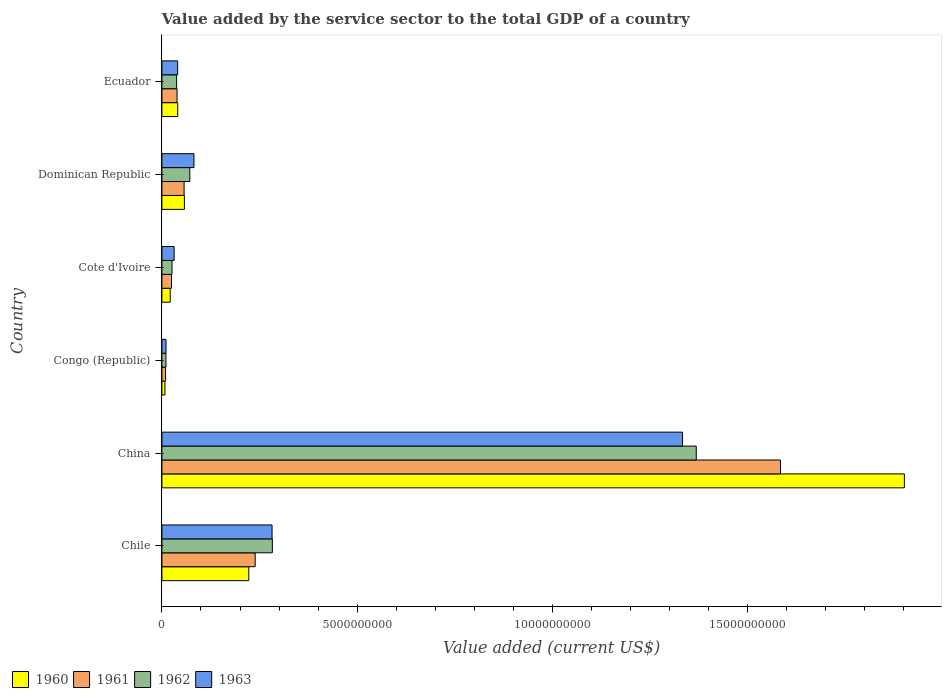How many different coloured bars are there?
Your response must be concise. 4. Are the number of bars on each tick of the Y-axis equal?
Offer a very short reply. Yes. How many bars are there on the 4th tick from the bottom?
Your response must be concise. 4. What is the label of the 4th group of bars from the top?
Your answer should be compact. Congo (Republic). What is the value added by the service sector to the total GDP in 1963 in China?
Ensure brevity in your answer.  1.33e+1. Across all countries, what is the maximum value added by the service sector to the total GDP in 1963?
Offer a very short reply. 1.33e+1. Across all countries, what is the minimum value added by the service sector to the total GDP in 1962?
Offer a very short reply. 1.04e+08. In which country was the value added by the service sector to the total GDP in 1962 minimum?
Your answer should be very brief. Congo (Republic). What is the total value added by the service sector to the total GDP in 1961 in the graph?
Ensure brevity in your answer.  1.95e+1. What is the difference between the value added by the service sector to the total GDP in 1960 in Congo (Republic) and that in Dominican Republic?
Provide a short and direct response. -4.98e+08. What is the difference between the value added by the service sector to the total GDP in 1962 in Chile and the value added by the service sector to the total GDP in 1963 in Congo (Republic)?
Offer a terse response. 2.72e+09. What is the average value added by the service sector to the total GDP in 1963 per country?
Offer a terse response. 2.97e+09. What is the difference between the value added by the service sector to the total GDP in 1961 and value added by the service sector to the total GDP in 1960 in Chile?
Your answer should be compact. 1.64e+08. In how many countries, is the value added by the service sector to the total GDP in 1960 greater than 3000000000 US$?
Give a very brief answer. 1. What is the ratio of the value added by the service sector to the total GDP in 1961 in Chile to that in Cote d'Ivoire?
Keep it short and to the point. 9.73. What is the difference between the highest and the second highest value added by the service sector to the total GDP in 1960?
Your answer should be compact. 1.68e+1. What is the difference between the highest and the lowest value added by the service sector to the total GDP in 1961?
Give a very brief answer. 1.57e+1. Is the sum of the value added by the service sector to the total GDP in 1961 in Dominican Republic and Ecuador greater than the maximum value added by the service sector to the total GDP in 1962 across all countries?
Give a very brief answer. No. Is it the case that in every country, the sum of the value added by the service sector to the total GDP in 1961 and value added by the service sector to the total GDP in 1962 is greater than the sum of value added by the service sector to the total GDP in 1960 and value added by the service sector to the total GDP in 1963?
Give a very brief answer. No. What does the 2nd bar from the bottom in Chile represents?
Keep it short and to the point. 1961. Is it the case that in every country, the sum of the value added by the service sector to the total GDP in 1963 and value added by the service sector to the total GDP in 1962 is greater than the value added by the service sector to the total GDP in 1960?
Your answer should be compact. Yes. Are all the bars in the graph horizontal?
Offer a very short reply. Yes. What is the difference between two consecutive major ticks on the X-axis?
Provide a short and direct response. 5.00e+09. How are the legend labels stacked?
Offer a terse response. Horizontal. What is the title of the graph?
Your response must be concise. Value added by the service sector to the total GDP of a country. What is the label or title of the X-axis?
Provide a succinct answer. Value added (current US$). What is the Value added (current US$) of 1960 in Chile?
Ensure brevity in your answer.  2.22e+09. What is the Value added (current US$) of 1961 in Chile?
Make the answer very short. 2.39e+09. What is the Value added (current US$) in 1962 in Chile?
Keep it short and to the point. 2.83e+09. What is the Value added (current US$) in 1963 in Chile?
Keep it short and to the point. 2.82e+09. What is the Value added (current US$) of 1960 in China?
Ensure brevity in your answer.  1.90e+1. What is the Value added (current US$) in 1961 in China?
Your answer should be very brief. 1.58e+1. What is the Value added (current US$) of 1962 in China?
Provide a succinct answer. 1.37e+1. What is the Value added (current US$) of 1963 in China?
Your response must be concise. 1.33e+1. What is the Value added (current US$) of 1960 in Congo (Republic)?
Ensure brevity in your answer.  7.82e+07. What is the Value added (current US$) in 1961 in Congo (Republic)?
Keep it short and to the point. 9.33e+07. What is the Value added (current US$) of 1962 in Congo (Republic)?
Give a very brief answer. 1.04e+08. What is the Value added (current US$) in 1963 in Congo (Republic)?
Keep it short and to the point. 1.06e+08. What is the Value added (current US$) in 1960 in Cote d'Ivoire?
Provide a succinct answer. 2.13e+08. What is the Value added (current US$) in 1961 in Cote d'Ivoire?
Keep it short and to the point. 2.46e+08. What is the Value added (current US$) in 1962 in Cote d'Ivoire?
Your response must be concise. 2.59e+08. What is the Value added (current US$) of 1963 in Cote d'Ivoire?
Give a very brief answer. 3.13e+08. What is the Value added (current US$) in 1960 in Dominican Republic?
Offer a very short reply. 5.76e+08. What is the Value added (current US$) of 1961 in Dominican Republic?
Offer a terse response. 5.68e+08. What is the Value added (current US$) of 1962 in Dominican Republic?
Your response must be concise. 7.14e+08. What is the Value added (current US$) of 1963 in Dominican Republic?
Give a very brief answer. 8.22e+08. What is the Value added (current US$) in 1960 in Ecuador?
Keep it short and to the point. 4.05e+08. What is the Value added (current US$) in 1961 in Ecuador?
Your answer should be compact. 3.88e+08. What is the Value added (current US$) of 1962 in Ecuador?
Provide a short and direct response. 3.77e+08. What is the Value added (current US$) of 1963 in Ecuador?
Offer a terse response. 4.03e+08. Across all countries, what is the maximum Value added (current US$) of 1960?
Offer a very short reply. 1.90e+1. Across all countries, what is the maximum Value added (current US$) in 1961?
Your response must be concise. 1.58e+1. Across all countries, what is the maximum Value added (current US$) of 1962?
Your response must be concise. 1.37e+1. Across all countries, what is the maximum Value added (current US$) in 1963?
Your answer should be compact. 1.33e+1. Across all countries, what is the minimum Value added (current US$) of 1960?
Keep it short and to the point. 7.82e+07. Across all countries, what is the minimum Value added (current US$) of 1961?
Offer a very short reply. 9.33e+07. Across all countries, what is the minimum Value added (current US$) of 1962?
Your answer should be compact. 1.04e+08. Across all countries, what is the minimum Value added (current US$) in 1963?
Provide a succinct answer. 1.06e+08. What is the total Value added (current US$) in 1960 in the graph?
Give a very brief answer. 2.25e+1. What is the total Value added (current US$) in 1961 in the graph?
Offer a very short reply. 1.95e+1. What is the total Value added (current US$) in 1962 in the graph?
Ensure brevity in your answer.  1.80e+1. What is the total Value added (current US$) of 1963 in the graph?
Make the answer very short. 1.78e+1. What is the difference between the Value added (current US$) in 1960 in Chile and that in China?
Your answer should be very brief. -1.68e+1. What is the difference between the Value added (current US$) of 1961 in Chile and that in China?
Offer a terse response. -1.35e+1. What is the difference between the Value added (current US$) of 1962 in Chile and that in China?
Ensure brevity in your answer.  -1.09e+1. What is the difference between the Value added (current US$) of 1963 in Chile and that in China?
Keep it short and to the point. -1.05e+1. What is the difference between the Value added (current US$) of 1960 in Chile and that in Congo (Republic)?
Your response must be concise. 2.15e+09. What is the difference between the Value added (current US$) in 1961 in Chile and that in Congo (Republic)?
Your response must be concise. 2.30e+09. What is the difference between the Value added (current US$) in 1962 in Chile and that in Congo (Republic)?
Your answer should be compact. 2.73e+09. What is the difference between the Value added (current US$) in 1963 in Chile and that in Congo (Republic)?
Provide a succinct answer. 2.72e+09. What is the difference between the Value added (current US$) in 1960 in Chile and that in Cote d'Ivoire?
Keep it short and to the point. 2.01e+09. What is the difference between the Value added (current US$) in 1961 in Chile and that in Cote d'Ivoire?
Offer a terse response. 2.14e+09. What is the difference between the Value added (current US$) in 1962 in Chile and that in Cote d'Ivoire?
Your answer should be compact. 2.57e+09. What is the difference between the Value added (current US$) of 1963 in Chile and that in Cote d'Ivoire?
Your answer should be very brief. 2.51e+09. What is the difference between the Value added (current US$) in 1960 in Chile and that in Dominican Republic?
Your response must be concise. 1.65e+09. What is the difference between the Value added (current US$) in 1961 in Chile and that in Dominican Republic?
Provide a succinct answer. 1.82e+09. What is the difference between the Value added (current US$) in 1962 in Chile and that in Dominican Republic?
Ensure brevity in your answer.  2.11e+09. What is the difference between the Value added (current US$) in 1963 in Chile and that in Dominican Republic?
Provide a succinct answer. 2.00e+09. What is the difference between the Value added (current US$) of 1960 in Chile and that in Ecuador?
Offer a terse response. 1.82e+09. What is the difference between the Value added (current US$) in 1961 in Chile and that in Ecuador?
Make the answer very short. 2.00e+09. What is the difference between the Value added (current US$) of 1962 in Chile and that in Ecuador?
Offer a terse response. 2.45e+09. What is the difference between the Value added (current US$) of 1963 in Chile and that in Ecuador?
Provide a short and direct response. 2.42e+09. What is the difference between the Value added (current US$) in 1960 in China and that in Congo (Republic)?
Your response must be concise. 1.89e+1. What is the difference between the Value added (current US$) of 1961 in China and that in Congo (Republic)?
Make the answer very short. 1.57e+1. What is the difference between the Value added (current US$) of 1962 in China and that in Congo (Republic)?
Your response must be concise. 1.36e+1. What is the difference between the Value added (current US$) in 1963 in China and that in Congo (Republic)?
Ensure brevity in your answer.  1.32e+1. What is the difference between the Value added (current US$) of 1960 in China and that in Cote d'Ivoire?
Provide a short and direct response. 1.88e+1. What is the difference between the Value added (current US$) in 1961 in China and that in Cote d'Ivoire?
Your answer should be compact. 1.56e+1. What is the difference between the Value added (current US$) of 1962 in China and that in Cote d'Ivoire?
Keep it short and to the point. 1.34e+1. What is the difference between the Value added (current US$) in 1963 in China and that in Cote d'Ivoire?
Give a very brief answer. 1.30e+1. What is the difference between the Value added (current US$) in 1960 in China and that in Dominican Republic?
Provide a succinct answer. 1.84e+1. What is the difference between the Value added (current US$) of 1961 in China and that in Dominican Republic?
Your answer should be very brief. 1.53e+1. What is the difference between the Value added (current US$) in 1962 in China and that in Dominican Republic?
Provide a succinct answer. 1.30e+1. What is the difference between the Value added (current US$) in 1963 in China and that in Dominican Republic?
Ensure brevity in your answer.  1.25e+1. What is the difference between the Value added (current US$) in 1960 in China and that in Ecuador?
Make the answer very short. 1.86e+1. What is the difference between the Value added (current US$) of 1961 in China and that in Ecuador?
Your answer should be compact. 1.55e+1. What is the difference between the Value added (current US$) of 1962 in China and that in Ecuador?
Provide a short and direct response. 1.33e+1. What is the difference between the Value added (current US$) in 1963 in China and that in Ecuador?
Keep it short and to the point. 1.29e+1. What is the difference between the Value added (current US$) of 1960 in Congo (Republic) and that in Cote d'Ivoire?
Make the answer very short. -1.35e+08. What is the difference between the Value added (current US$) in 1961 in Congo (Republic) and that in Cote d'Ivoire?
Provide a succinct answer. -1.52e+08. What is the difference between the Value added (current US$) in 1962 in Congo (Republic) and that in Cote d'Ivoire?
Your answer should be very brief. -1.55e+08. What is the difference between the Value added (current US$) of 1963 in Congo (Republic) and that in Cote d'Ivoire?
Make the answer very short. -2.08e+08. What is the difference between the Value added (current US$) of 1960 in Congo (Republic) and that in Dominican Republic?
Provide a succinct answer. -4.98e+08. What is the difference between the Value added (current US$) of 1961 in Congo (Republic) and that in Dominican Republic?
Ensure brevity in your answer.  -4.75e+08. What is the difference between the Value added (current US$) in 1962 in Congo (Republic) and that in Dominican Republic?
Provide a short and direct response. -6.11e+08. What is the difference between the Value added (current US$) of 1963 in Congo (Republic) and that in Dominican Republic?
Offer a terse response. -7.16e+08. What is the difference between the Value added (current US$) in 1960 in Congo (Republic) and that in Ecuador?
Offer a terse response. -3.27e+08. What is the difference between the Value added (current US$) in 1961 in Congo (Republic) and that in Ecuador?
Your answer should be compact. -2.95e+08. What is the difference between the Value added (current US$) in 1962 in Congo (Republic) and that in Ecuador?
Offer a very short reply. -2.73e+08. What is the difference between the Value added (current US$) of 1963 in Congo (Republic) and that in Ecuador?
Provide a succinct answer. -2.98e+08. What is the difference between the Value added (current US$) in 1960 in Cote d'Ivoire and that in Dominican Republic?
Keep it short and to the point. -3.63e+08. What is the difference between the Value added (current US$) of 1961 in Cote d'Ivoire and that in Dominican Republic?
Your answer should be compact. -3.23e+08. What is the difference between the Value added (current US$) of 1962 in Cote d'Ivoire and that in Dominican Republic?
Ensure brevity in your answer.  -4.56e+08. What is the difference between the Value added (current US$) of 1963 in Cote d'Ivoire and that in Dominican Republic?
Provide a short and direct response. -5.09e+08. What is the difference between the Value added (current US$) of 1960 in Cote d'Ivoire and that in Ecuador?
Give a very brief answer. -1.92e+08. What is the difference between the Value added (current US$) of 1961 in Cote d'Ivoire and that in Ecuador?
Give a very brief answer. -1.42e+08. What is the difference between the Value added (current US$) of 1962 in Cote d'Ivoire and that in Ecuador?
Provide a succinct answer. -1.18e+08. What is the difference between the Value added (current US$) in 1963 in Cote d'Ivoire and that in Ecuador?
Make the answer very short. -9.04e+07. What is the difference between the Value added (current US$) in 1960 in Dominican Republic and that in Ecuador?
Keep it short and to the point. 1.71e+08. What is the difference between the Value added (current US$) of 1961 in Dominican Republic and that in Ecuador?
Offer a very short reply. 1.81e+08. What is the difference between the Value added (current US$) in 1962 in Dominican Republic and that in Ecuador?
Your answer should be very brief. 3.38e+08. What is the difference between the Value added (current US$) in 1963 in Dominican Republic and that in Ecuador?
Your answer should be very brief. 4.18e+08. What is the difference between the Value added (current US$) in 1960 in Chile and the Value added (current US$) in 1961 in China?
Give a very brief answer. -1.36e+1. What is the difference between the Value added (current US$) of 1960 in Chile and the Value added (current US$) of 1962 in China?
Make the answer very short. -1.15e+1. What is the difference between the Value added (current US$) of 1960 in Chile and the Value added (current US$) of 1963 in China?
Provide a short and direct response. -1.11e+1. What is the difference between the Value added (current US$) in 1961 in Chile and the Value added (current US$) in 1962 in China?
Your answer should be very brief. -1.13e+1. What is the difference between the Value added (current US$) of 1961 in Chile and the Value added (current US$) of 1963 in China?
Ensure brevity in your answer.  -1.09e+1. What is the difference between the Value added (current US$) in 1962 in Chile and the Value added (current US$) in 1963 in China?
Your answer should be compact. -1.05e+1. What is the difference between the Value added (current US$) in 1960 in Chile and the Value added (current US$) in 1961 in Congo (Republic)?
Give a very brief answer. 2.13e+09. What is the difference between the Value added (current US$) in 1960 in Chile and the Value added (current US$) in 1962 in Congo (Republic)?
Ensure brevity in your answer.  2.12e+09. What is the difference between the Value added (current US$) in 1960 in Chile and the Value added (current US$) in 1963 in Congo (Republic)?
Your answer should be compact. 2.12e+09. What is the difference between the Value added (current US$) of 1961 in Chile and the Value added (current US$) of 1962 in Congo (Republic)?
Ensure brevity in your answer.  2.29e+09. What is the difference between the Value added (current US$) of 1961 in Chile and the Value added (current US$) of 1963 in Congo (Republic)?
Provide a succinct answer. 2.28e+09. What is the difference between the Value added (current US$) in 1962 in Chile and the Value added (current US$) in 1963 in Congo (Republic)?
Ensure brevity in your answer.  2.72e+09. What is the difference between the Value added (current US$) in 1960 in Chile and the Value added (current US$) in 1961 in Cote d'Ivoire?
Give a very brief answer. 1.98e+09. What is the difference between the Value added (current US$) of 1960 in Chile and the Value added (current US$) of 1962 in Cote d'Ivoire?
Ensure brevity in your answer.  1.97e+09. What is the difference between the Value added (current US$) in 1960 in Chile and the Value added (current US$) in 1963 in Cote d'Ivoire?
Offer a very short reply. 1.91e+09. What is the difference between the Value added (current US$) of 1961 in Chile and the Value added (current US$) of 1962 in Cote d'Ivoire?
Offer a terse response. 2.13e+09. What is the difference between the Value added (current US$) in 1961 in Chile and the Value added (current US$) in 1963 in Cote d'Ivoire?
Give a very brief answer. 2.08e+09. What is the difference between the Value added (current US$) in 1962 in Chile and the Value added (current US$) in 1963 in Cote d'Ivoire?
Offer a very short reply. 2.52e+09. What is the difference between the Value added (current US$) of 1960 in Chile and the Value added (current US$) of 1961 in Dominican Republic?
Your response must be concise. 1.66e+09. What is the difference between the Value added (current US$) of 1960 in Chile and the Value added (current US$) of 1962 in Dominican Republic?
Your answer should be compact. 1.51e+09. What is the difference between the Value added (current US$) in 1960 in Chile and the Value added (current US$) in 1963 in Dominican Republic?
Your response must be concise. 1.40e+09. What is the difference between the Value added (current US$) in 1961 in Chile and the Value added (current US$) in 1962 in Dominican Republic?
Offer a terse response. 1.67e+09. What is the difference between the Value added (current US$) of 1961 in Chile and the Value added (current US$) of 1963 in Dominican Republic?
Your answer should be compact. 1.57e+09. What is the difference between the Value added (current US$) of 1962 in Chile and the Value added (current US$) of 1963 in Dominican Republic?
Offer a terse response. 2.01e+09. What is the difference between the Value added (current US$) of 1960 in Chile and the Value added (current US$) of 1961 in Ecuador?
Give a very brief answer. 1.84e+09. What is the difference between the Value added (current US$) of 1960 in Chile and the Value added (current US$) of 1962 in Ecuador?
Your answer should be compact. 1.85e+09. What is the difference between the Value added (current US$) of 1960 in Chile and the Value added (current US$) of 1963 in Ecuador?
Offer a terse response. 1.82e+09. What is the difference between the Value added (current US$) in 1961 in Chile and the Value added (current US$) in 1962 in Ecuador?
Offer a very short reply. 2.01e+09. What is the difference between the Value added (current US$) in 1961 in Chile and the Value added (current US$) in 1963 in Ecuador?
Ensure brevity in your answer.  1.99e+09. What is the difference between the Value added (current US$) of 1962 in Chile and the Value added (current US$) of 1963 in Ecuador?
Provide a short and direct response. 2.43e+09. What is the difference between the Value added (current US$) of 1960 in China and the Value added (current US$) of 1961 in Congo (Republic)?
Ensure brevity in your answer.  1.89e+1. What is the difference between the Value added (current US$) of 1960 in China and the Value added (current US$) of 1962 in Congo (Republic)?
Keep it short and to the point. 1.89e+1. What is the difference between the Value added (current US$) of 1960 in China and the Value added (current US$) of 1963 in Congo (Republic)?
Provide a succinct answer. 1.89e+1. What is the difference between the Value added (current US$) of 1961 in China and the Value added (current US$) of 1962 in Congo (Republic)?
Your answer should be very brief. 1.57e+1. What is the difference between the Value added (current US$) in 1961 in China and the Value added (current US$) in 1963 in Congo (Republic)?
Make the answer very short. 1.57e+1. What is the difference between the Value added (current US$) in 1962 in China and the Value added (current US$) in 1963 in Congo (Republic)?
Make the answer very short. 1.36e+1. What is the difference between the Value added (current US$) in 1960 in China and the Value added (current US$) in 1961 in Cote d'Ivoire?
Make the answer very short. 1.88e+1. What is the difference between the Value added (current US$) in 1960 in China and the Value added (current US$) in 1962 in Cote d'Ivoire?
Offer a terse response. 1.88e+1. What is the difference between the Value added (current US$) of 1960 in China and the Value added (current US$) of 1963 in Cote d'Ivoire?
Provide a short and direct response. 1.87e+1. What is the difference between the Value added (current US$) in 1961 in China and the Value added (current US$) in 1962 in Cote d'Ivoire?
Offer a very short reply. 1.56e+1. What is the difference between the Value added (current US$) in 1961 in China and the Value added (current US$) in 1963 in Cote d'Ivoire?
Provide a short and direct response. 1.55e+1. What is the difference between the Value added (current US$) of 1962 in China and the Value added (current US$) of 1963 in Cote d'Ivoire?
Make the answer very short. 1.34e+1. What is the difference between the Value added (current US$) in 1960 in China and the Value added (current US$) in 1961 in Dominican Republic?
Give a very brief answer. 1.84e+1. What is the difference between the Value added (current US$) in 1960 in China and the Value added (current US$) in 1962 in Dominican Republic?
Offer a very short reply. 1.83e+1. What is the difference between the Value added (current US$) in 1960 in China and the Value added (current US$) in 1963 in Dominican Republic?
Provide a short and direct response. 1.82e+1. What is the difference between the Value added (current US$) in 1961 in China and the Value added (current US$) in 1962 in Dominican Republic?
Offer a very short reply. 1.51e+1. What is the difference between the Value added (current US$) in 1961 in China and the Value added (current US$) in 1963 in Dominican Republic?
Provide a succinct answer. 1.50e+1. What is the difference between the Value added (current US$) of 1962 in China and the Value added (current US$) of 1963 in Dominican Republic?
Your answer should be very brief. 1.29e+1. What is the difference between the Value added (current US$) of 1960 in China and the Value added (current US$) of 1961 in Ecuador?
Provide a short and direct response. 1.86e+1. What is the difference between the Value added (current US$) in 1960 in China and the Value added (current US$) in 1962 in Ecuador?
Give a very brief answer. 1.86e+1. What is the difference between the Value added (current US$) in 1960 in China and the Value added (current US$) in 1963 in Ecuador?
Your answer should be very brief. 1.86e+1. What is the difference between the Value added (current US$) in 1961 in China and the Value added (current US$) in 1962 in Ecuador?
Provide a succinct answer. 1.55e+1. What is the difference between the Value added (current US$) of 1961 in China and the Value added (current US$) of 1963 in Ecuador?
Ensure brevity in your answer.  1.54e+1. What is the difference between the Value added (current US$) of 1962 in China and the Value added (current US$) of 1963 in Ecuador?
Ensure brevity in your answer.  1.33e+1. What is the difference between the Value added (current US$) in 1960 in Congo (Republic) and the Value added (current US$) in 1961 in Cote d'Ivoire?
Keep it short and to the point. -1.67e+08. What is the difference between the Value added (current US$) in 1960 in Congo (Republic) and the Value added (current US$) in 1962 in Cote d'Ivoire?
Offer a very short reply. -1.81e+08. What is the difference between the Value added (current US$) of 1960 in Congo (Republic) and the Value added (current US$) of 1963 in Cote d'Ivoire?
Give a very brief answer. -2.35e+08. What is the difference between the Value added (current US$) of 1961 in Congo (Republic) and the Value added (current US$) of 1962 in Cote d'Ivoire?
Keep it short and to the point. -1.66e+08. What is the difference between the Value added (current US$) of 1961 in Congo (Republic) and the Value added (current US$) of 1963 in Cote d'Ivoire?
Offer a very short reply. -2.20e+08. What is the difference between the Value added (current US$) in 1962 in Congo (Republic) and the Value added (current US$) in 1963 in Cote d'Ivoire?
Your response must be concise. -2.09e+08. What is the difference between the Value added (current US$) of 1960 in Congo (Republic) and the Value added (current US$) of 1961 in Dominican Republic?
Give a very brief answer. -4.90e+08. What is the difference between the Value added (current US$) in 1960 in Congo (Republic) and the Value added (current US$) in 1962 in Dominican Republic?
Keep it short and to the point. -6.36e+08. What is the difference between the Value added (current US$) in 1960 in Congo (Republic) and the Value added (current US$) in 1963 in Dominican Republic?
Provide a succinct answer. -7.43e+08. What is the difference between the Value added (current US$) of 1961 in Congo (Republic) and the Value added (current US$) of 1962 in Dominican Republic?
Ensure brevity in your answer.  -6.21e+08. What is the difference between the Value added (current US$) of 1961 in Congo (Republic) and the Value added (current US$) of 1963 in Dominican Republic?
Offer a very short reply. -7.28e+08. What is the difference between the Value added (current US$) in 1962 in Congo (Republic) and the Value added (current US$) in 1963 in Dominican Republic?
Give a very brief answer. -7.18e+08. What is the difference between the Value added (current US$) of 1960 in Congo (Republic) and the Value added (current US$) of 1961 in Ecuador?
Your answer should be very brief. -3.10e+08. What is the difference between the Value added (current US$) in 1960 in Congo (Republic) and the Value added (current US$) in 1962 in Ecuador?
Make the answer very short. -2.99e+08. What is the difference between the Value added (current US$) in 1960 in Congo (Republic) and the Value added (current US$) in 1963 in Ecuador?
Keep it short and to the point. -3.25e+08. What is the difference between the Value added (current US$) in 1961 in Congo (Republic) and the Value added (current US$) in 1962 in Ecuador?
Your answer should be compact. -2.84e+08. What is the difference between the Value added (current US$) in 1961 in Congo (Republic) and the Value added (current US$) in 1963 in Ecuador?
Keep it short and to the point. -3.10e+08. What is the difference between the Value added (current US$) of 1962 in Congo (Republic) and the Value added (current US$) of 1963 in Ecuador?
Your response must be concise. -3.00e+08. What is the difference between the Value added (current US$) in 1960 in Cote d'Ivoire and the Value added (current US$) in 1961 in Dominican Republic?
Keep it short and to the point. -3.56e+08. What is the difference between the Value added (current US$) in 1960 in Cote d'Ivoire and the Value added (current US$) in 1962 in Dominican Republic?
Offer a terse response. -5.02e+08. What is the difference between the Value added (current US$) of 1960 in Cote d'Ivoire and the Value added (current US$) of 1963 in Dominican Republic?
Your answer should be compact. -6.09e+08. What is the difference between the Value added (current US$) of 1961 in Cote d'Ivoire and the Value added (current US$) of 1962 in Dominican Republic?
Provide a succinct answer. -4.69e+08. What is the difference between the Value added (current US$) of 1961 in Cote d'Ivoire and the Value added (current US$) of 1963 in Dominican Republic?
Your answer should be compact. -5.76e+08. What is the difference between the Value added (current US$) in 1962 in Cote d'Ivoire and the Value added (current US$) in 1963 in Dominican Republic?
Keep it short and to the point. -5.63e+08. What is the difference between the Value added (current US$) of 1960 in Cote d'Ivoire and the Value added (current US$) of 1961 in Ecuador?
Your response must be concise. -1.75e+08. What is the difference between the Value added (current US$) in 1960 in Cote d'Ivoire and the Value added (current US$) in 1962 in Ecuador?
Provide a succinct answer. -1.64e+08. What is the difference between the Value added (current US$) in 1960 in Cote d'Ivoire and the Value added (current US$) in 1963 in Ecuador?
Your response must be concise. -1.91e+08. What is the difference between the Value added (current US$) in 1961 in Cote d'Ivoire and the Value added (current US$) in 1962 in Ecuador?
Offer a terse response. -1.31e+08. What is the difference between the Value added (current US$) of 1961 in Cote d'Ivoire and the Value added (current US$) of 1963 in Ecuador?
Ensure brevity in your answer.  -1.58e+08. What is the difference between the Value added (current US$) of 1962 in Cote d'Ivoire and the Value added (current US$) of 1963 in Ecuador?
Your answer should be compact. -1.45e+08. What is the difference between the Value added (current US$) in 1960 in Dominican Republic and the Value added (current US$) in 1961 in Ecuador?
Your answer should be very brief. 1.88e+08. What is the difference between the Value added (current US$) in 1960 in Dominican Republic and the Value added (current US$) in 1962 in Ecuador?
Give a very brief answer. 1.99e+08. What is the difference between the Value added (current US$) in 1960 in Dominican Republic and the Value added (current US$) in 1963 in Ecuador?
Provide a succinct answer. 1.73e+08. What is the difference between the Value added (current US$) of 1961 in Dominican Republic and the Value added (current US$) of 1962 in Ecuador?
Give a very brief answer. 1.92e+08. What is the difference between the Value added (current US$) in 1961 in Dominican Republic and the Value added (current US$) in 1963 in Ecuador?
Give a very brief answer. 1.65e+08. What is the difference between the Value added (current US$) of 1962 in Dominican Republic and the Value added (current US$) of 1963 in Ecuador?
Your answer should be compact. 3.11e+08. What is the average Value added (current US$) in 1960 per country?
Provide a short and direct response. 3.75e+09. What is the average Value added (current US$) of 1961 per country?
Provide a succinct answer. 3.25e+09. What is the average Value added (current US$) in 1962 per country?
Offer a terse response. 2.99e+09. What is the average Value added (current US$) of 1963 per country?
Offer a terse response. 2.97e+09. What is the difference between the Value added (current US$) in 1960 and Value added (current US$) in 1961 in Chile?
Provide a succinct answer. -1.64e+08. What is the difference between the Value added (current US$) of 1960 and Value added (current US$) of 1962 in Chile?
Ensure brevity in your answer.  -6.04e+08. What is the difference between the Value added (current US$) in 1960 and Value added (current US$) in 1963 in Chile?
Provide a short and direct response. -5.96e+08. What is the difference between the Value added (current US$) of 1961 and Value added (current US$) of 1962 in Chile?
Give a very brief answer. -4.40e+08. What is the difference between the Value added (current US$) in 1961 and Value added (current US$) in 1963 in Chile?
Keep it short and to the point. -4.32e+08. What is the difference between the Value added (current US$) of 1962 and Value added (current US$) of 1963 in Chile?
Make the answer very short. 8.01e+06. What is the difference between the Value added (current US$) in 1960 and Value added (current US$) in 1961 in China?
Provide a succinct answer. 3.17e+09. What is the difference between the Value added (current US$) of 1960 and Value added (current US$) of 1962 in China?
Make the answer very short. 5.33e+09. What is the difference between the Value added (current US$) of 1960 and Value added (current US$) of 1963 in China?
Your answer should be very brief. 5.68e+09. What is the difference between the Value added (current US$) in 1961 and Value added (current US$) in 1962 in China?
Keep it short and to the point. 2.16e+09. What is the difference between the Value added (current US$) in 1961 and Value added (current US$) in 1963 in China?
Offer a very short reply. 2.51e+09. What is the difference between the Value added (current US$) of 1962 and Value added (current US$) of 1963 in China?
Your answer should be compact. 3.53e+08. What is the difference between the Value added (current US$) in 1960 and Value added (current US$) in 1961 in Congo (Republic)?
Provide a succinct answer. -1.51e+07. What is the difference between the Value added (current US$) in 1960 and Value added (current US$) in 1962 in Congo (Republic)?
Provide a short and direct response. -2.55e+07. What is the difference between the Value added (current US$) in 1960 and Value added (current US$) in 1963 in Congo (Republic)?
Give a very brief answer. -2.73e+07. What is the difference between the Value added (current US$) in 1961 and Value added (current US$) in 1962 in Congo (Republic)?
Make the answer very short. -1.05e+07. What is the difference between the Value added (current US$) in 1961 and Value added (current US$) in 1963 in Congo (Republic)?
Offer a terse response. -1.23e+07. What is the difference between the Value added (current US$) of 1962 and Value added (current US$) of 1963 in Congo (Republic)?
Offer a very short reply. -1.79e+06. What is the difference between the Value added (current US$) in 1960 and Value added (current US$) in 1961 in Cote d'Ivoire?
Give a very brief answer. -3.28e+07. What is the difference between the Value added (current US$) in 1960 and Value added (current US$) in 1962 in Cote d'Ivoire?
Offer a very short reply. -4.61e+07. What is the difference between the Value added (current US$) of 1960 and Value added (current US$) of 1963 in Cote d'Ivoire?
Your answer should be very brief. -1.00e+08. What is the difference between the Value added (current US$) of 1961 and Value added (current US$) of 1962 in Cote d'Ivoire?
Provide a succinct answer. -1.33e+07. What is the difference between the Value added (current US$) of 1961 and Value added (current US$) of 1963 in Cote d'Ivoire?
Offer a terse response. -6.75e+07. What is the difference between the Value added (current US$) in 1962 and Value added (current US$) in 1963 in Cote d'Ivoire?
Your response must be concise. -5.42e+07. What is the difference between the Value added (current US$) in 1960 and Value added (current US$) in 1961 in Dominican Republic?
Your answer should be very brief. 7.50e+06. What is the difference between the Value added (current US$) of 1960 and Value added (current US$) of 1962 in Dominican Republic?
Make the answer very short. -1.39e+08. What is the difference between the Value added (current US$) in 1960 and Value added (current US$) in 1963 in Dominican Republic?
Your answer should be very brief. -2.46e+08. What is the difference between the Value added (current US$) in 1961 and Value added (current US$) in 1962 in Dominican Republic?
Ensure brevity in your answer.  -1.46e+08. What is the difference between the Value added (current US$) of 1961 and Value added (current US$) of 1963 in Dominican Republic?
Your response must be concise. -2.53e+08. What is the difference between the Value added (current US$) of 1962 and Value added (current US$) of 1963 in Dominican Republic?
Offer a very short reply. -1.07e+08. What is the difference between the Value added (current US$) in 1960 and Value added (current US$) in 1961 in Ecuador?
Keep it short and to the point. 1.69e+07. What is the difference between the Value added (current US$) in 1960 and Value added (current US$) in 1962 in Ecuador?
Give a very brief answer. 2.79e+07. What is the difference between the Value added (current US$) in 1960 and Value added (current US$) in 1963 in Ecuador?
Ensure brevity in your answer.  1.47e+06. What is the difference between the Value added (current US$) of 1961 and Value added (current US$) of 1962 in Ecuador?
Your answer should be compact. 1.10e+07. What is the difference between the Value added (current US$) of 1961 and Value added (current US$) of 1963 in Ecuador?
Keep it short and to the point. -1.54e+07. What is the difference between the Value added (current US$) of 1962 and Value added (current US$) of 1963 in Ecuador?
Your response must be concise. -2.64e+07. What is the ratio of the Value added (current US$) of 1960 in Chile to that in China?
Make the answer very short. 0.12. What is the ratio of the Value added (current US$) in 1961 in Chile to that in China?
Give a very brief answer. 0.15. What is the ratio of the Value added (current US$) of 1962 in Chile to that in China?
Ensure brevity in your answer.  0.21. What is the ratio of the Value added (current US$) in 1963 in Chile to that in China?
Offer a terse response. 0.21. What is the ratio of the Value added (current US$) of 1960 in Chile to that in Congo (Republic)?
Offer a terse response. 28.44. What is the ratio of the Value added (current US$) of 1961 in Chile to that in Congo (Republic)?
Offer a very short reply. 25.61. What is the ratio of the Value added (current US$) in 1962 in Chile to that in Congo (Republic)?
Offer a very short reply. 27.27. What is the ratio of the Value added (current US$) in 1963 in Chile to that in Congo (Republic)?
Provide a succinct answer. 26.73. What is the ratio of the Value added (current US$) of 1960 in Chile to that in Cote d'Ivoire?
Provide a succinct answer. 10.45. What is the ratio of the Value added (current US$) in 1961 in Chile to that in Cote d'Ivoire?
Make the answer very short. 9.73. What is the ratio of the Value added (current US$) in 1962 in Chile to that in Cote d'Ivoire?
Give a very brief answer. 10.93. What is the ratio of the Value added (current US$) of 1963 in Chile to that in Cote d'Ivoire?
Provide a succinct answer. 9.01. What is the ratio of the Value added (current US$) of 1960 in Chile to that in Dominican Republic?
Make the answer very short. 3.86. What is the ratio of the Value added (current US$) of 1961 in Chile to that in Dominican Republic?
Offer a terse response. 4.2. What is the ratio of the Value added (current US$) in 1962 in Chile to that in Dominican Republic?
Your answer should be very brief. 3.96. What is the ratio of the Value added (current US$) of 1963 in Chile to that in Dominican Republic?
Give a very brief answer. 3.43. What is the ratio of the Value added (current US$) in 1960 in Chile to that in Ecuador?
Provide a succinct answer. 5.49. What is the ratio of the Value added (current US$) of 1961 in Chile to that in Ecuador?
Offer a very short reply. 6.16. What is the ratio of the Value added (current US$) in 1962 in Chile to that in Ecuador?
Your answer should be compact. 7.5. What is the ratio of the Value added (current US$) of 1963 in Chile to that in Ecuador?
Provide a succinct answer. 6.99. What is the ratio of the Value added (current US$) in 1960 in China to that in Congo (Republic)?
Give a very brief answer. 243.12. What is the ratio of the Value added (current US$) of 1961 in China to that in Congo (Republic)?
Ensure brevity in your answer.  169.84. What is the ratio of the Value added (current US$) of 1962 in China to that in Congo (Republic)?
Offer a very short reply. 131.91. What is the ratio of the Value added (current US$) in 1963 in China to that in Congo (Republic)?
Give a very brief answer. 126.33. What is the ratio of the Value added (current US$) of 1960 in China to that in Cote d'Ivoire?
Keep it short and to the point. 89.37. What is the ratio of the Value added (current US$) of 1961 in China to that in Cote d'Ivoire?
Make the answer very short. 64.52. What is the ratio of the Value added (current US$) in 1962 in China to that in Cote d'Ivoire?
Your response must be concise. 52.87. What is the ratio of the Value added (current US$) of 1963 in China to that in Cote d'Ivoire?
Give a very brief answer. 42.59. What is the ratio of the Value added (current US$) in 1960 in China to that in Dominican Republic?
Provide a succinct answer. 33.01. What is the ratio of the Value added (current US$) of 1961 in China to that in Dominican Republic?
Your answer should be compact. 27.87. What is the ratio of the Value added (current US$) in 1962 in China to that in Dominican Republic?
Keep it short and to the point. 19.15. What is the ratio of the Value added (current US$) in 1963 in China to that in Dominican Republic?
Give a very brief answer. 16.23. What is the ratio of the Value added (current US$) of 1960 in China to that in Ecuador?
Provide a succinct answer. 46.96. What is the ratio of the Value added (current US$) in 1961 in China to that in Ecuador?
Keep it short and to the point. 40.83. What is the ratio of the Value added (current US$) of 1962 in China to that in Ecuador?
Provide a succinct answer. 36.3. What is the ratio of the Value added (current US$) of 1963 in China to that in Ecuador?
Keep it short and to the point. 33.05. What is the ratio of the Value added (current US$) in 1960 in Congo (Republic) to that in Cote d'Ivoire?
Ensure brevity in your answer.  0.37. What is the ratio of the Value added (current US$) of 1961 in Congo (Republic) to that in Cote d'Ivoire?
Offer a terse response. 0.38. What is the ratio of the Value added (current US$) in 1962 in Congo (Republic) to that in Cote d'Ivoire?
Your response must be concise. 0.4. What is the ratio of the Value added (current US$) of 1963 in Congo (Republic) to that in Cote d'Ivoire?
Ensure brevity in your answer.  0.34. What is the ratio of the Value added (current US$) in 1960 in Congo (Republic) to that in Dominican Republic?
Ensure brevity in your answer.  0.14. What is the ratio of the Value added (current US$) of 1961 in Congo (Republic) to that in Dominican Republic?
Your answer should be compact. 0.16. What is the ratio of the Value added (current US$) in 1962 in Congo (Republic) to that in Dominican Republic?
Make the answer very short. 0.15. What is the ratio of the Value added (current US$) of 1963 in Congo (Republic) to that in Dominican Republic?
Ensure brevity in your answer.  0.13. What is the ratio of the Value added (current US$) of 1960 in Congo (Republic) to that in Ecuador?
Offer a terse response. 0.19. What is the ratio of the Value added (current US$) of 1961 in Congo (Republic) to that in Ecuador?
Your response must be concise. 0.24. What is the ratio of the Value added (current US$) in 1962 in Congo (Republic) to that in Ecuador?
Make the answer very short. 0.28. What is the ratio of the Value added (current US$) of 1963 in Congo (Republic) to that in Ecuador?
Provide a succinct answer. 0.26. What is the ratio of the Value added (current US$) in 1960 in Cote d'Ivoire to that in Dominican Republic?
Make the answer very short. 0.37. What is the ratio of the Value added (current US$) of 1961 in Cote d'Ivoire to that in Dominican Republic?
Your response must be concise. 0.43. What is the ratio of the Value added (current US$) in 1962 in Cote d'Ivoire to that in Dominican Republic?
Offer a very short reply. 0.36. What is the ratio of the Value added (current US$) in 1963 in Cote d'Ivoire to that in Dominican Republic?
Ensure brevity in your answer.  0.38. What is the ratio of the Value added (current US$) of 1960 in Cote d'Ivoire to that in Ecuador?
Keep it short and to the point. 0.53. What is the ratio of the Value added (current US$) in 1961 in Cote d'Ivoire to that in Ecuador?
Your response must be concise. 0.63. What is the ratio of the Value added (current US$) in 1962 in Cote d'Ivoire to that in Ecuador?
Provide a succinct answer. 0.69. What is the ratio of the Value added (current US$) in 1963 in Cote d'Ivoire to that in Ecuador?
Ensure brevity in your answer.  0.78. What is the ratio of the Value added (current US$) of 1960 in Dominican Republic to that in Ecuador?
Make the answer very short. 1.42. What is the ratio of the Value added (current US$) in 1961 in Dominican Republic to that in Ecuador?
Ensure brevity in your answer.  1.47. What is the ratio of the Value added (current US$) in 1962 in Dominican Republic to that in Ecuador?
Provide a short and direct response. 1.9. What is the ratio of the Value added (current US$) of 1963 in Dominican Republic to that in Ecuador?
Offer a very short reply. 2.04. What is the difference between the highest and the second highest Value added (current US$) of 1960?
Give a very brief answer. 1.68e+1. What is the difference between the highest and the second highest Value added (current US$) of 1961?
Offer a very short reply. 1.35e+1. What is the difference between the highest and the second highest Value added (current US$) in 1962?
Offer a terse response. 1.09e+1. What is the difference between the highest and the second highest Value added (current US$) in 1963?
Your response must be concise. 1.05e+1. What is the difference between the highest and the lowest Value added (current US$) of 1960?
Provide a short and direct response. 1.89e+1. What is the difference between the highest and the lowest Value added (current US$) in 1961?
Provide a succinct answer. 1.57e+1. What is the difference between the highest and the lowest Value added (current US$) in 1962?
Make the answer very short. 1.36e+1. What is the difference between the highest and the lowest Value added (current US$) of 1963?
Give a very brief answer. 1.32e+1. 